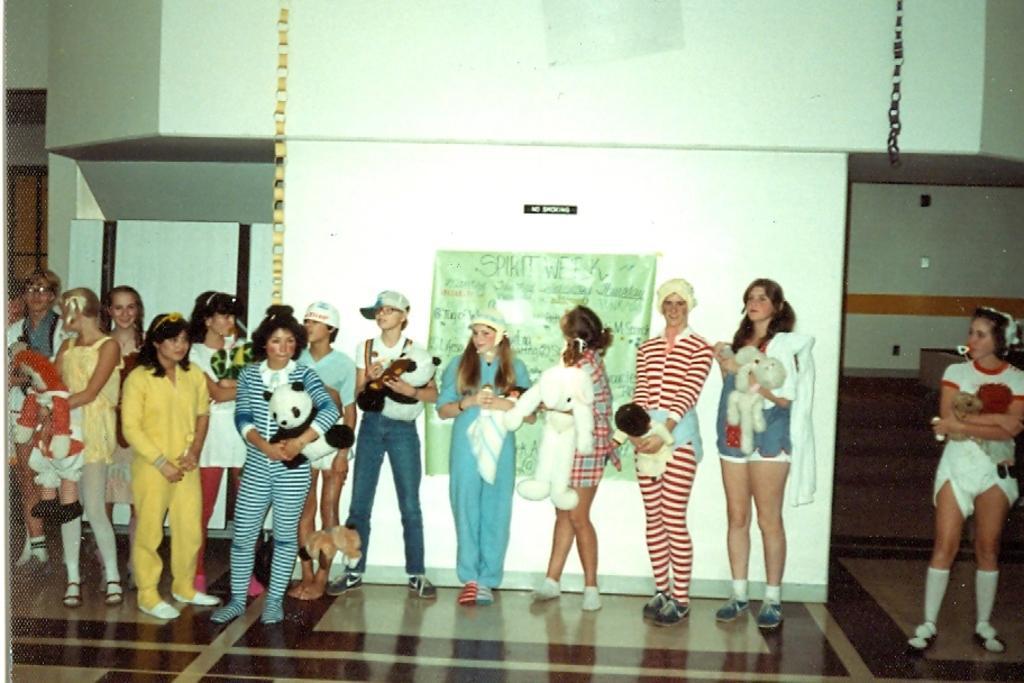How would you summarize this image in a sentence or two? The picture is taken in a room. In the foreground of the picture there are people standing, holding toys. Behind them there is a banner. In the background it is wall, painted white. 